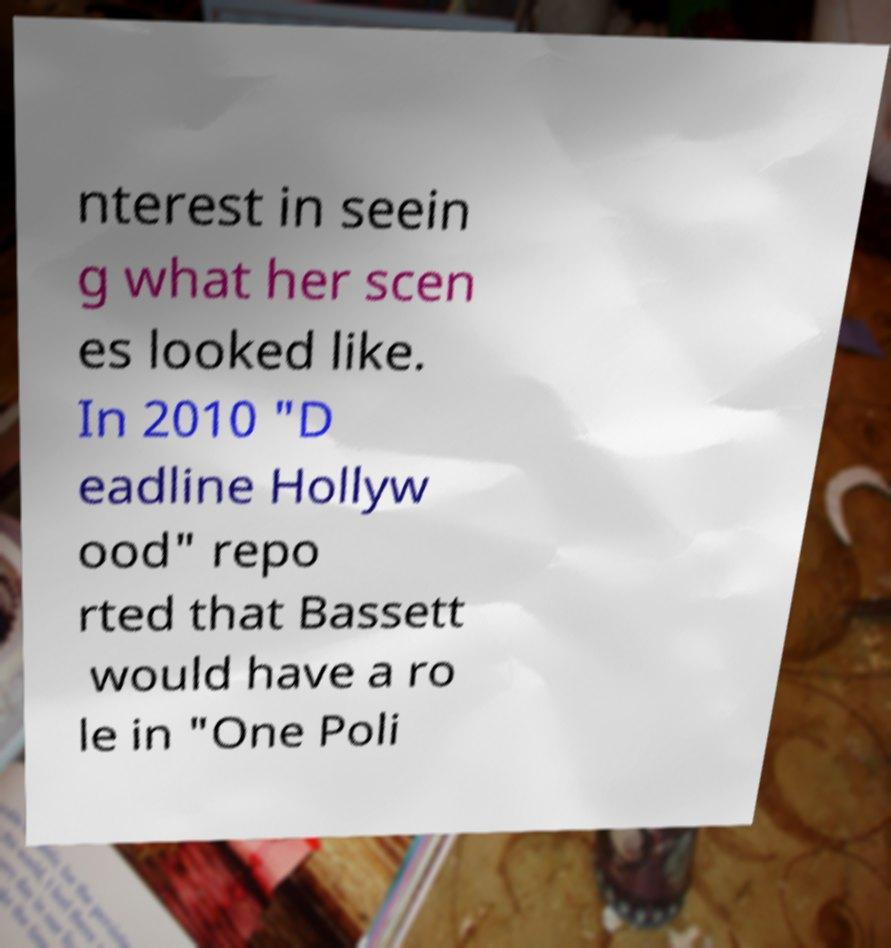Please read and relay the text visible in this image. What does it say? nterest in seein g what her scen es looked like. In 2010 "D eadline Hollyw ood" repo rted that Bassett would have a ro le in "One Poli 